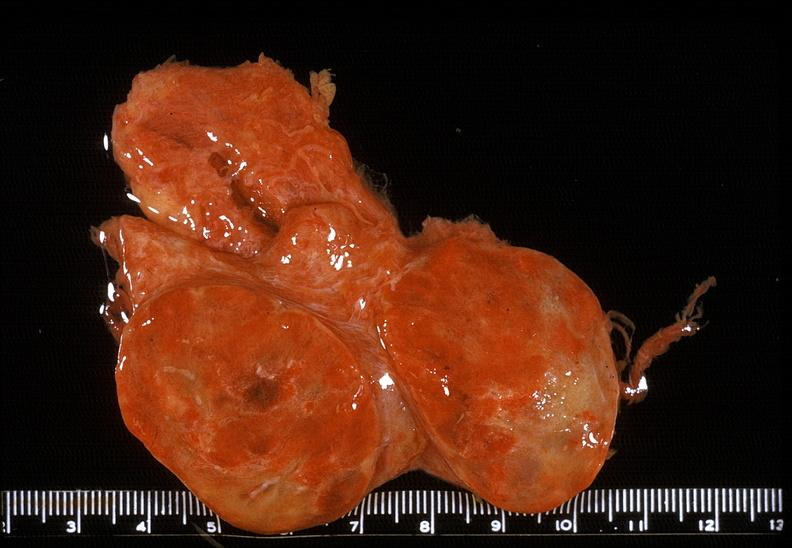what is present?
Answer the question using a single word or phrase. Endocrine 